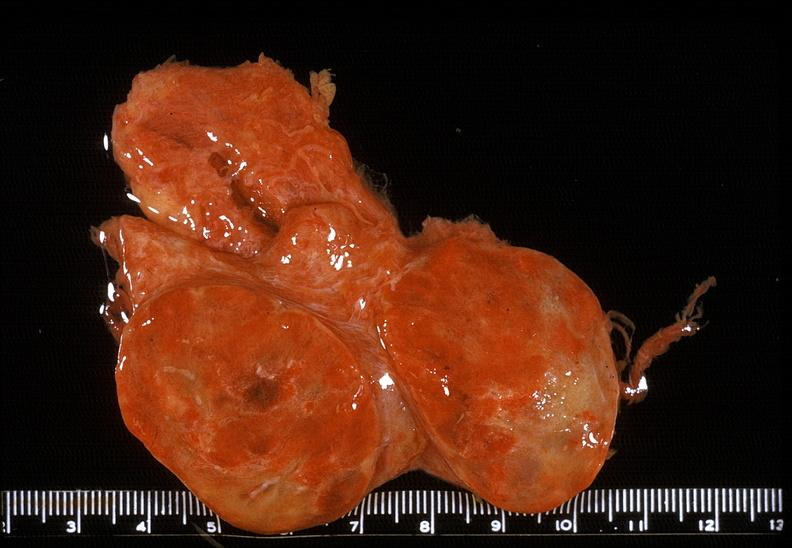what is present?
Answer the question using a single word or phrase. Endocrine 